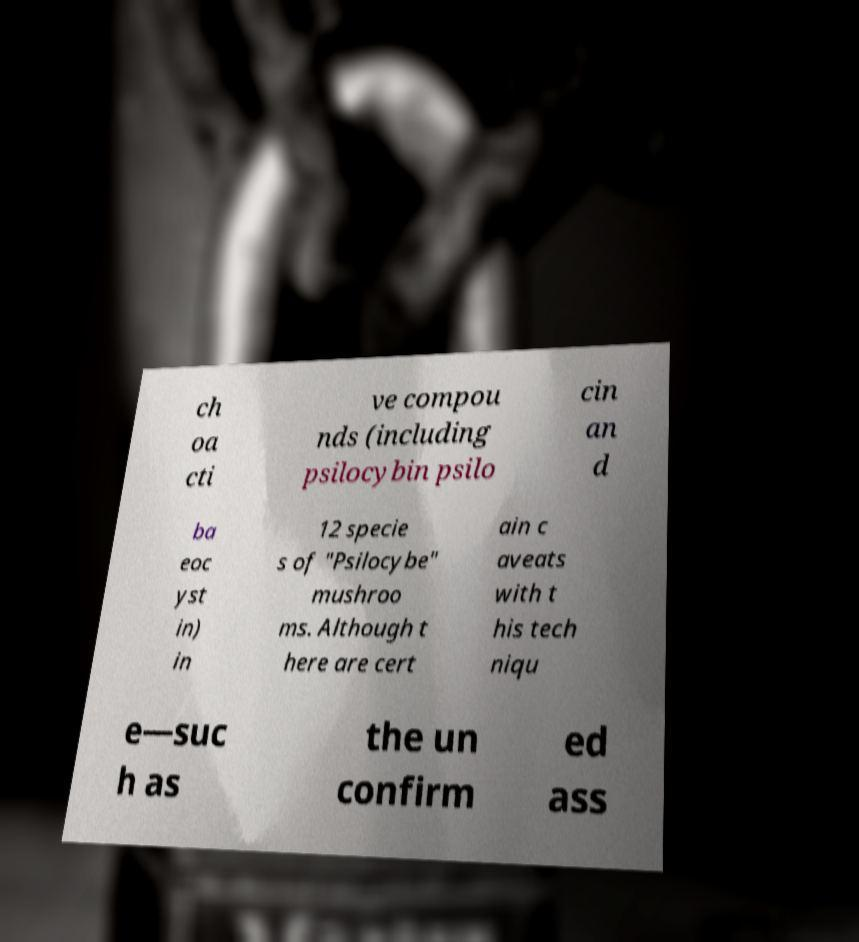Can you accurately transcribe the text from the provided image for me? ch oa cti ve compou nds (including psilocybin psilo cin an d ba eoc yst in) in 12 specie s of "Psilocybe" mushroo ms. Although t here are cert ain c aveats with t his tech niqu e—suc h as the un confirm ed ass 